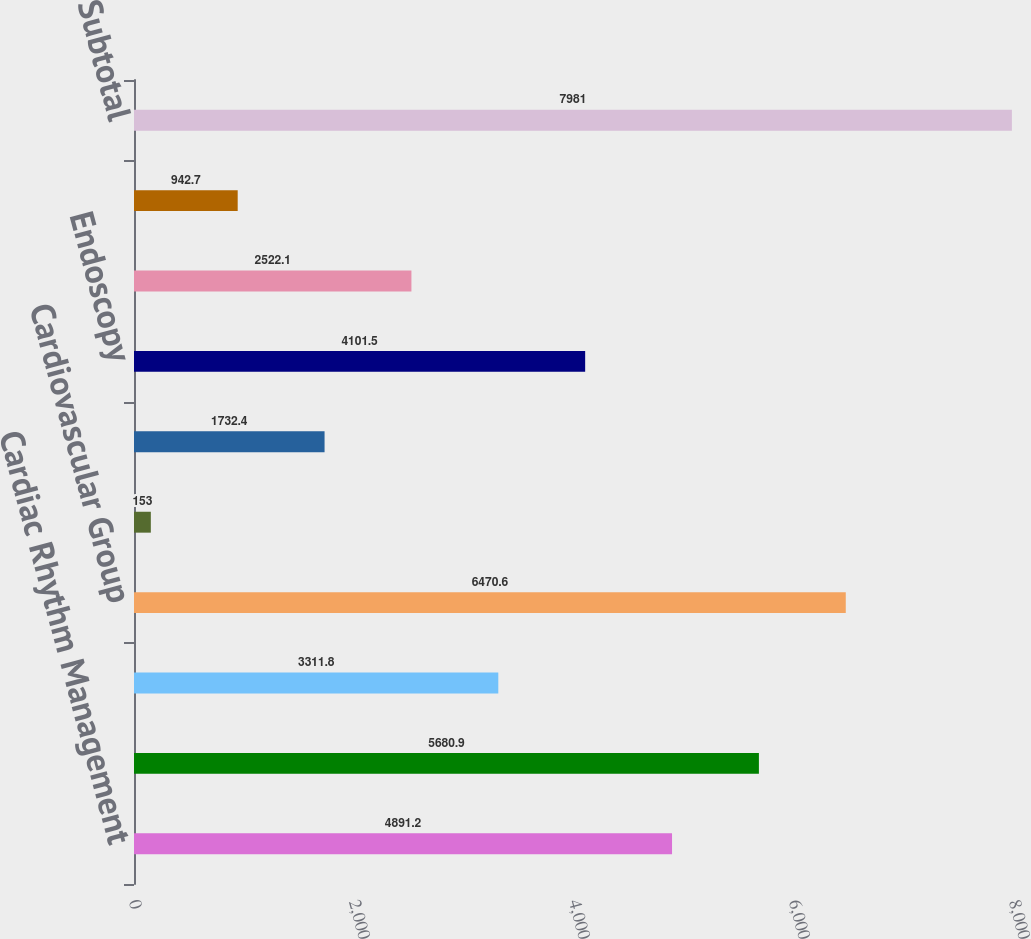<chart> <loc_0><loc_0><loc_500><loc_500><bar_chart><fcel>Cardiac Rhythm Management<fcel>Interventional Cardiology<fcel>Peripheral Interventions<fcel>Cardiovascular Group<fcel>Electrophysiology<fcel>Neurovascular<fcel>Endoscopy<fcel>Urology/Women's Health<fcel>Neuromodulation<fcel>Subtotal<nl><fcel>4891.2<fcel>5680.9<fcel>3311.8<fcel>6470.6<fcel>153<fcel>1732.4<fcel>4101.5<fcel>2522.1<fcel>942.7<fcel>7981<nl></chart> 